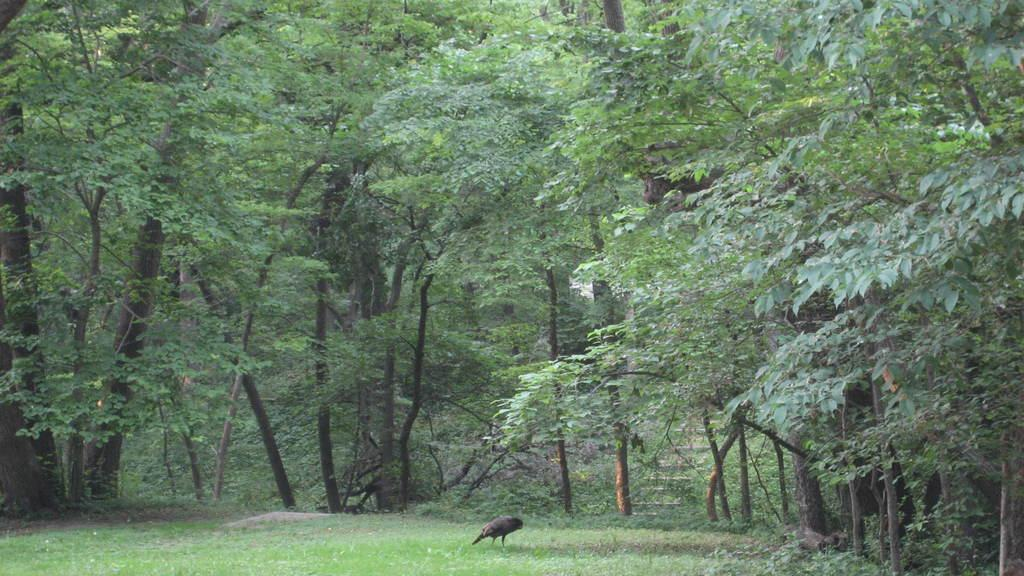What type of animal is in the image? There is a bird in the image. Where is the bird located? The bird is standing on the grass. What can be seen in the background of the image? There are trees in the background of the image. What architectural feature is visible in the image? There are stairs visible in the image. What type of toy is the bird playing with in the image? There is no toy present in the image, and the bird is not shown playing with anything. 